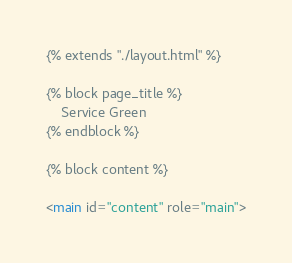Convert code to text. <code><loc_0><loc_0><loc_500><loc_500><_HTML_>{% extends "./layout.html" %}

{% block page_title %}
	Service Green
{% endblock %}

{% block content %}

<main id="content" role="main">
</code> 